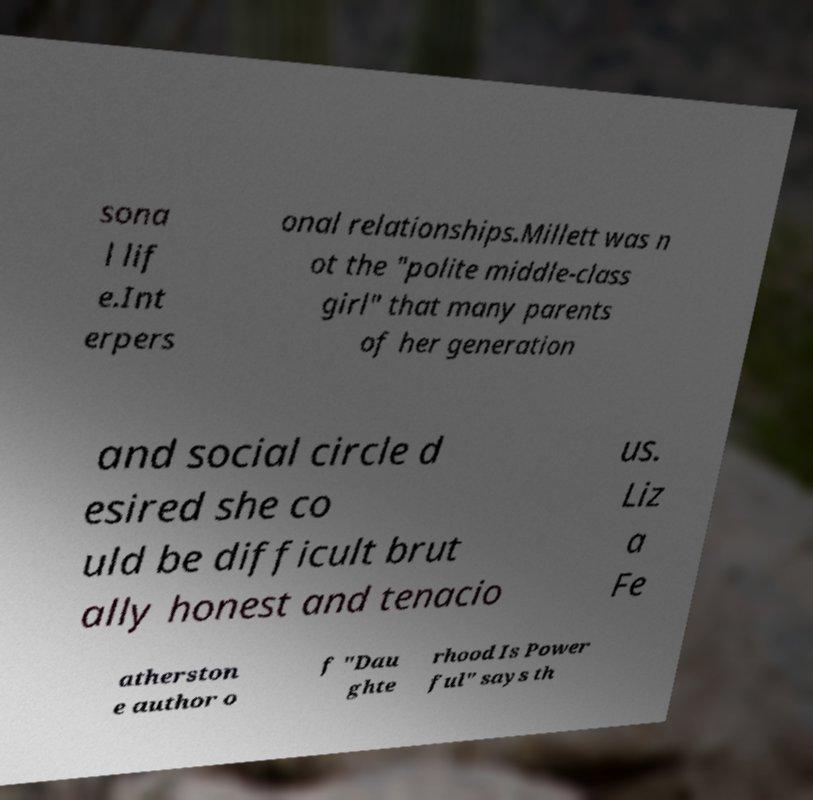Could you extract and type out the text from this image? sona l lif e.Int erpers onal relationships.Millett was n ot the "polite middle-class girl" that many parents of her generation and social circle d esired she co uld be difficult brut ally honest and tenacio us. Liz a Fe atherston e author o f "Dau ghte rhood Is Power ful" says th 